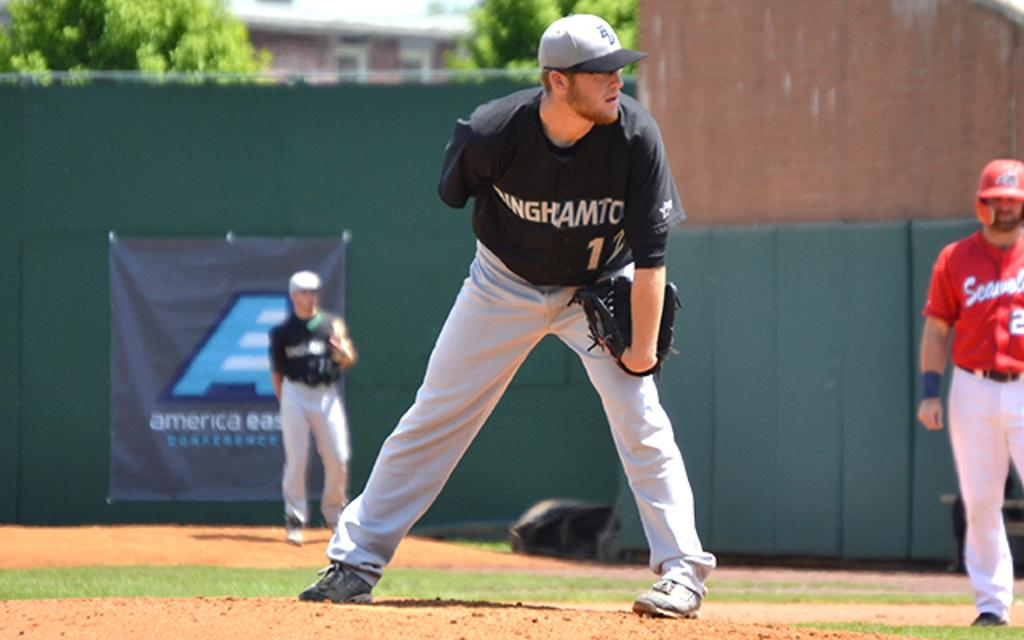<image>
Write a terse but informative summary of the picture. A baseball game is underway and the field has a sign that says America East. 